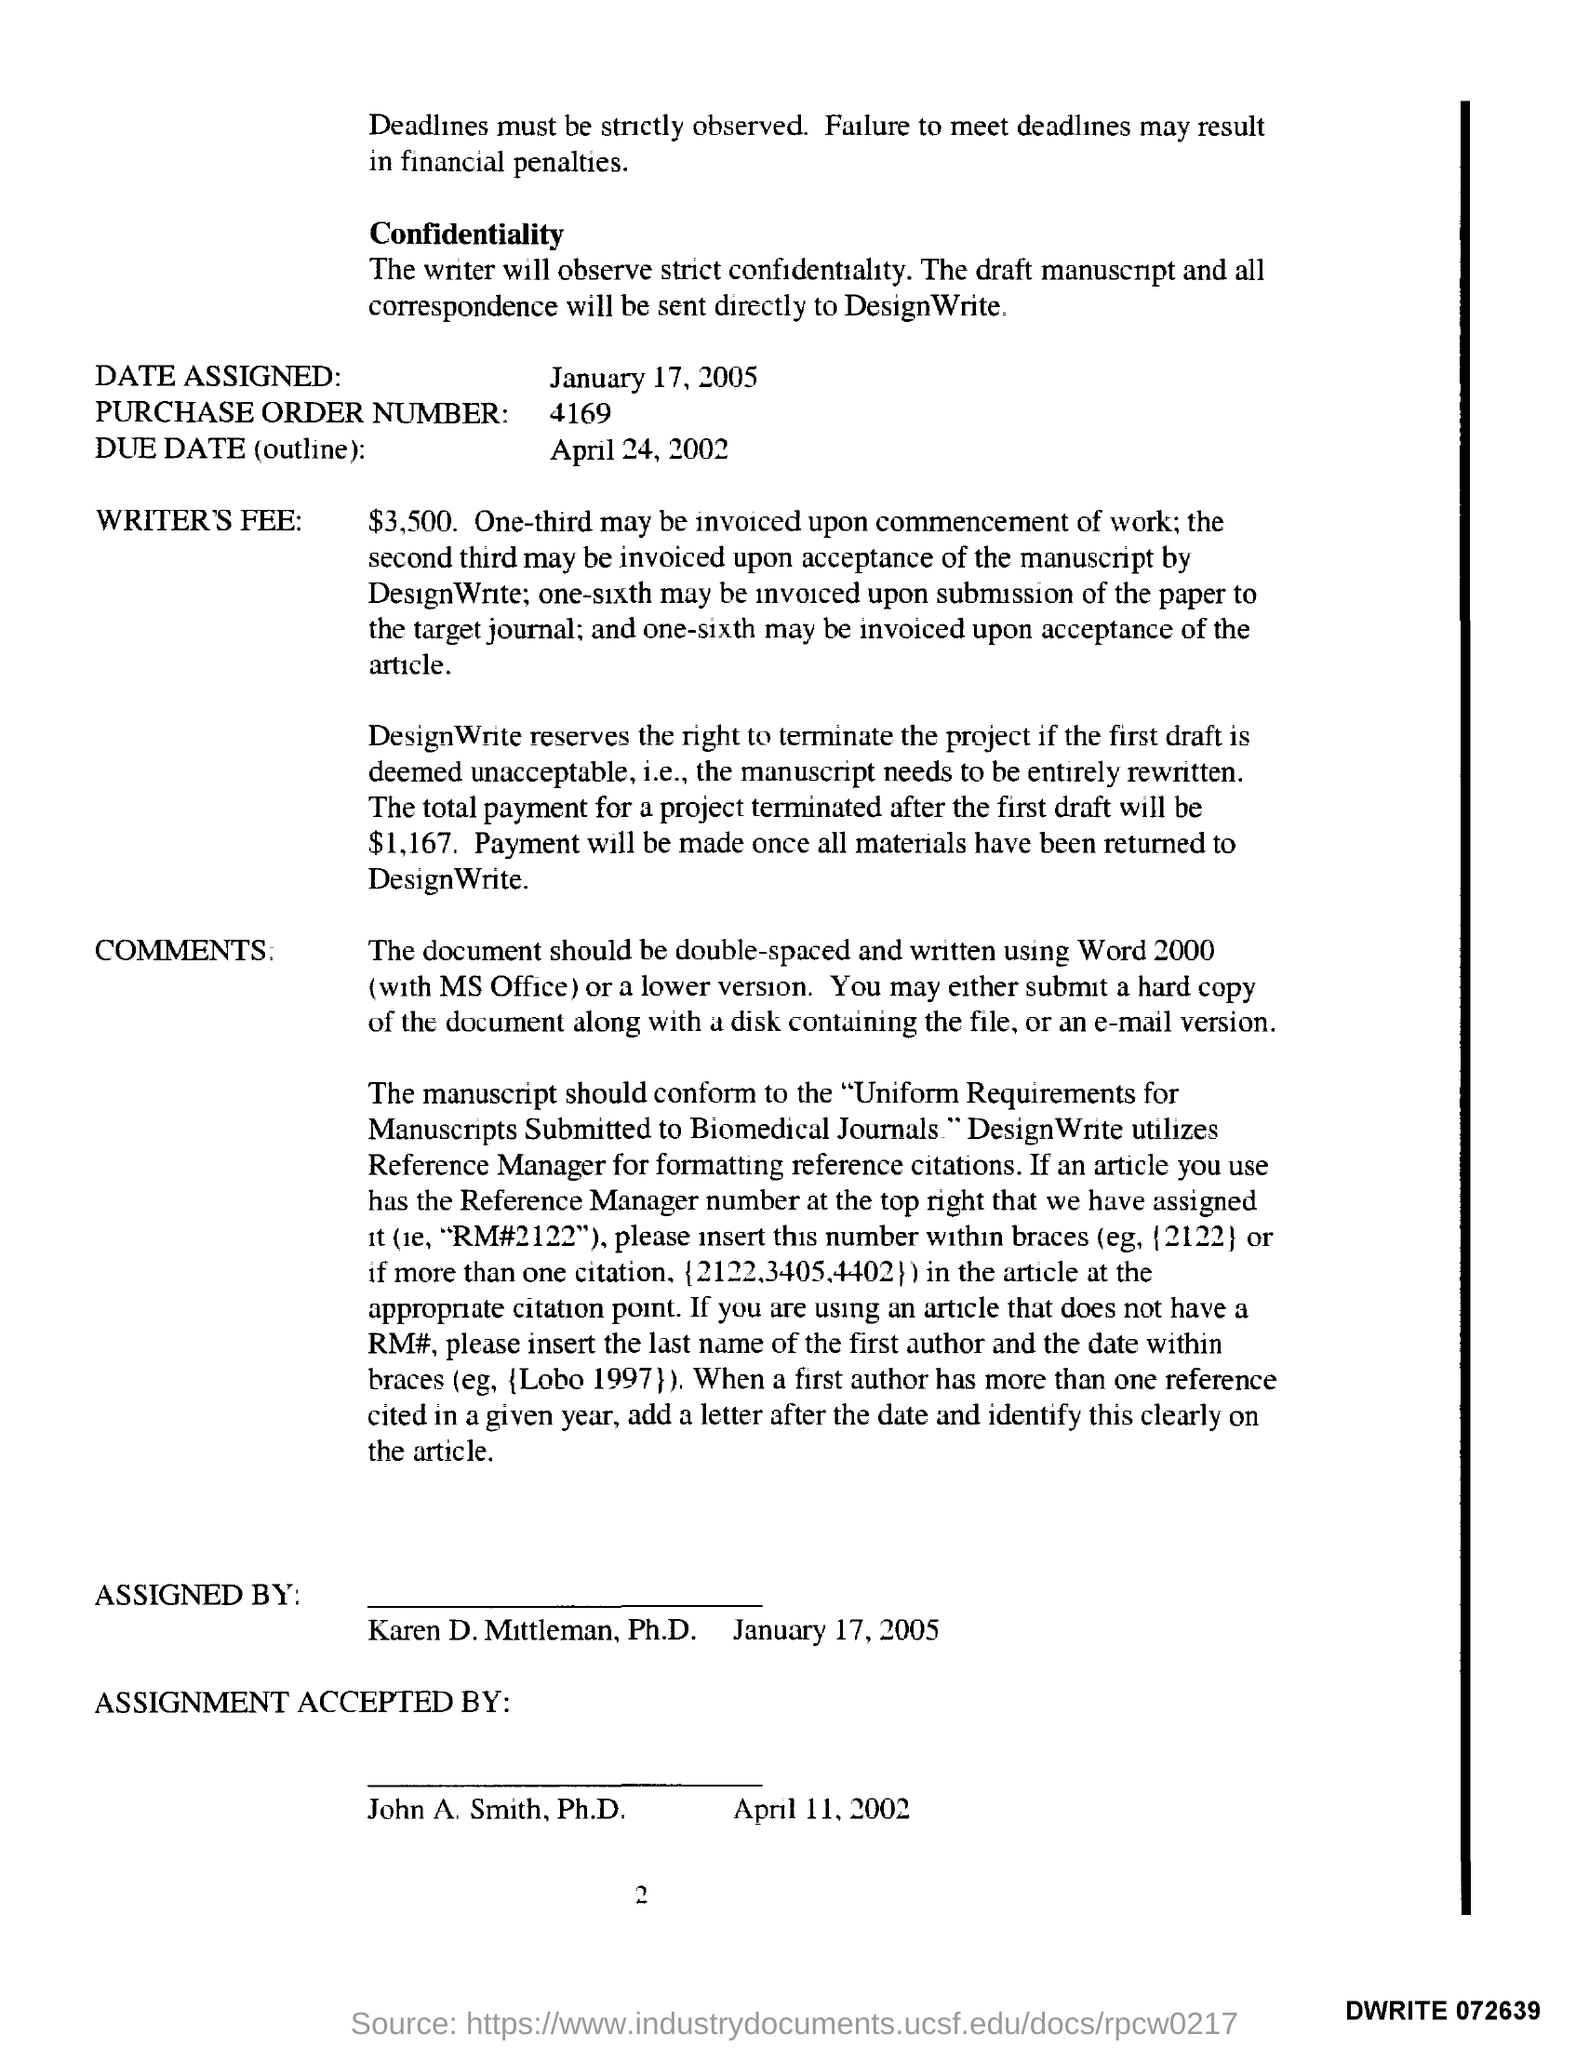What is the date assigned?
Offer a very short reply. January 17, 2005. What is the purchase order number?
Offer a terse response. 4169. What is the due date(outline)?
Provide a succinct answer. April 24, 2002. Who is assignment accepted?
Offer a terse response. John A. Smith. 